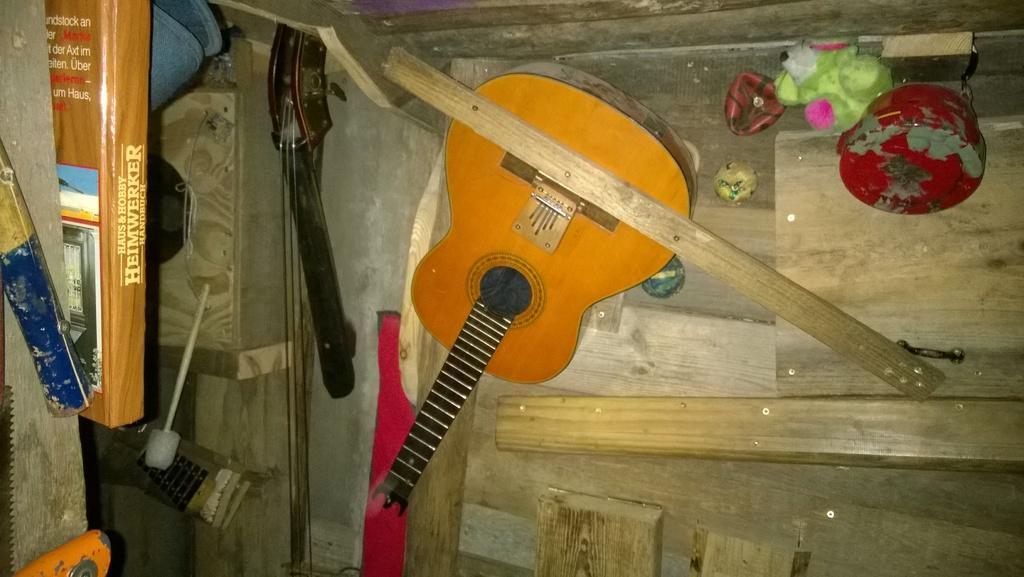What type of door is visible in the image? There is a wooden door in the image. What musical instrument can be seen in the image? There is a guitar in the image. What object related to reading is present in the image? There is a book in the image. What type of rice is being cooked in the image? There is no rice present in the image. What feeling is being expressed by the guitar in the image? The guitar is an inanimate object and cannot express feelings. 